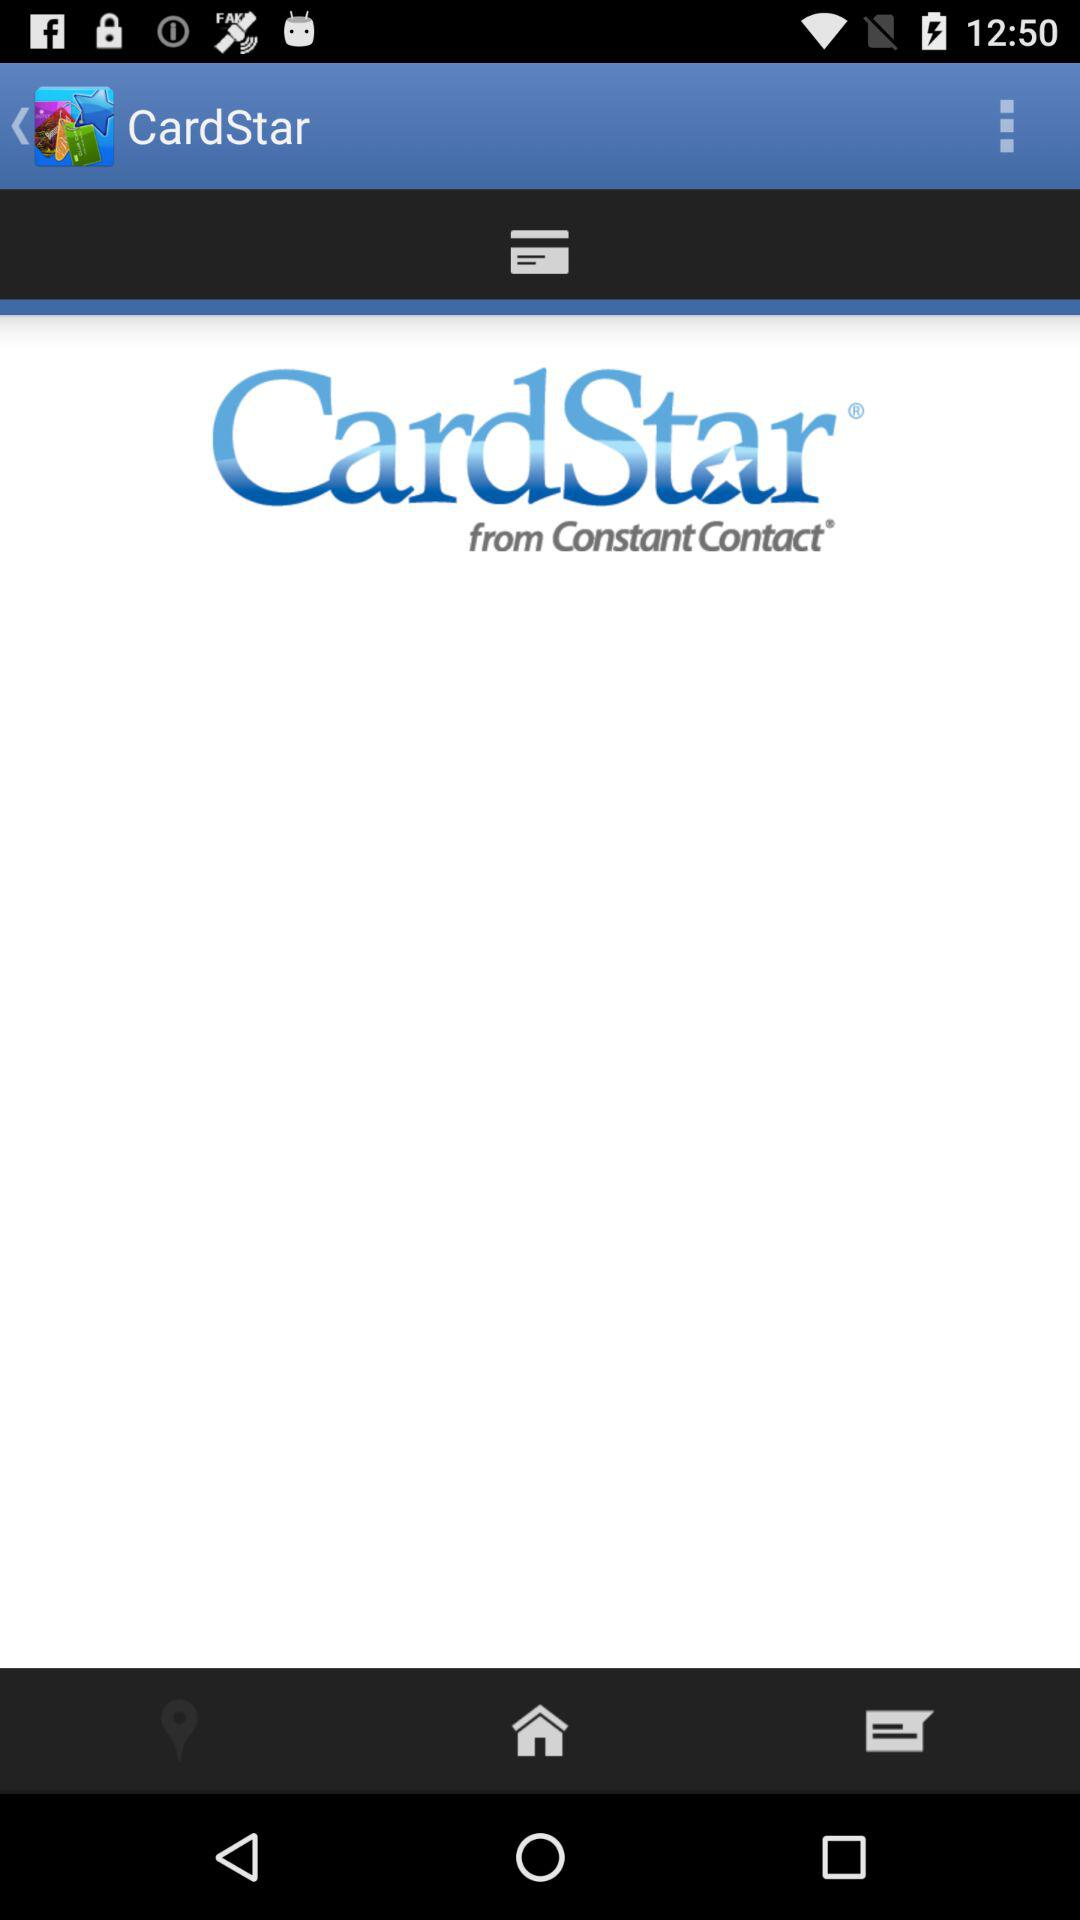What is the name of the application? The name of the application is "CardStar". 